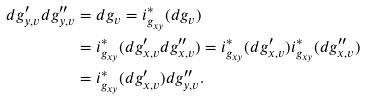Convert formula to latex. <formula><loc_0><loc_0><loc_500><loc_500>d g _ { y , v } ^ { \prime } d g ^ { \prime \prime } _ { y , v } & = d g _ { v } = i _ { g _ { x y } } ^ { * } ( d g _ { v } ) \\ & = i _ { g _ { x y } } ^ { * } ( d g _ { x , v } ^ { \prime } d g ^ { \prime \prime } _ { x , v } ) = i _ { g _ { x y } } ^ { * } ( d g _ { x , v } ^ { \prime } ) i _ { g _ { x y } } ^ { * } ( d g ^ { \prime \prime } _ { x , v } ) \\ & = i _ { g _ { x y } } ^ { * } ( d g _ { x , v } ^ { \prime } ) d g ^ { \prime \prime } _ { y , v } .</formula> 